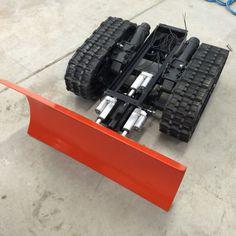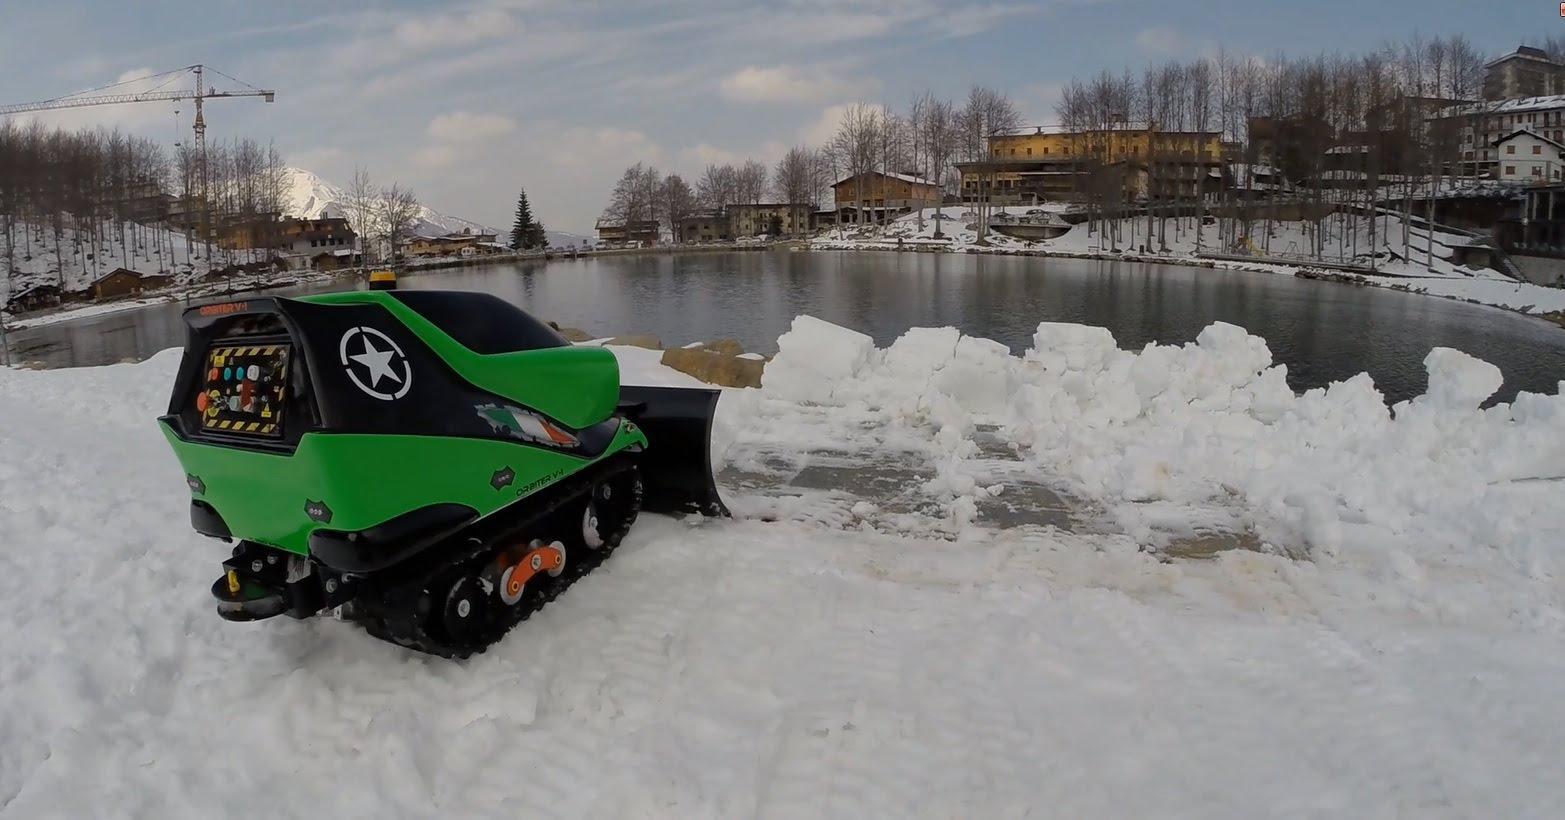The first image is the image on the left, the second image is the image on the right. For the images displayed, is the sentence "The left and right image contains the same number of snow vehicle with at least one green vehicle." factually correct? Answer yes or no. Yes. The first image is the image on the left, the second image is the image on the right. Examine the images to the left and right. Is the description "The plows in the left and right images face opposite directions, and the left image features an orange plow on a surface without snow, while the right image features a green vehicle on a snow-covered surface." accurate? Answer yes or no. Yes. 